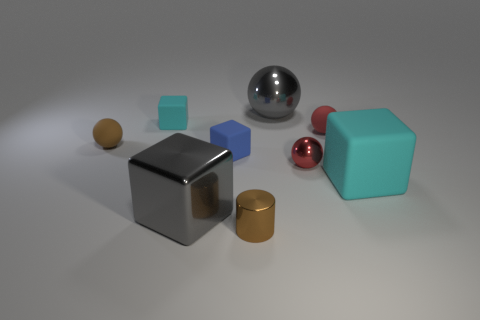There is a small metallic object to the right of the big metal thing behind the large gray shiny cube; what color is it?
Keep it short and to the point. Red. Do the brown cylinder and the gray metallic block have the same size?
Keep it short and to the point. No. There is a matte object that is right of the blue matte cube and left of the big cyan object; what is its color?
Offer a very short reply. Red. What size is the brown rubber ball?
Ensure brevity in your answer.  Small. There is a metal ball behind the brown ball; does it have the same color as the big metal cube?
Your answer should be very brief. Yes. Is the number of big gray objects that are to the left of the tiny blue rubber cube greater than the number of small metallic things that are behind the brown rubber ball?
Your answer should be compact. Yes. Are there more blue cubes than tiny red cubes?
Your answer should be compact. Yes. There is a rubber object that is both behind the brown matte ball and on the right side of the tiny brown cylinder; what is its size?
Ensure brevity in your answer.  Small. The brown shiny object has what shape?
Offer a terse response. Cylinder. Is there any other thing that has the same size as the blue block?
Offer a very short reply. Yes. 